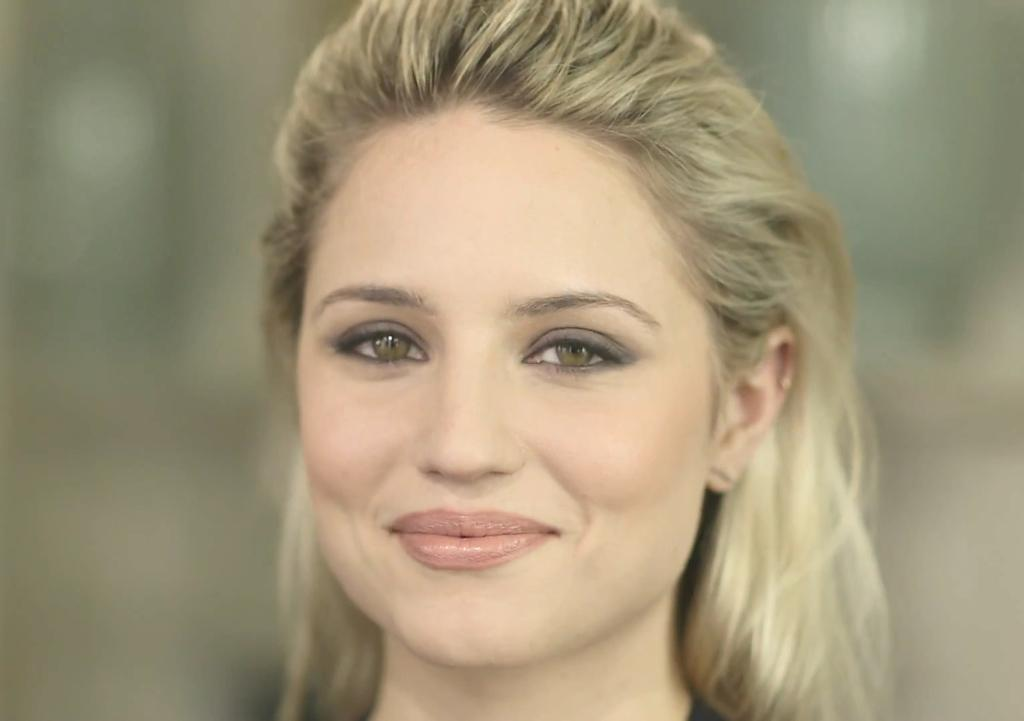Who is present in the image? There is a woman in the image. What expression does the woman have? The woman is smiling. Can you describe the background of the image? The background of the image is blurry. How many sticks does the woman have in her hand in the image? There are no sticks visible in the woman's hand in the image. What type of legs does the woman have in the image? The image does not show the woman's legs, so it is impossible to determine their type. 